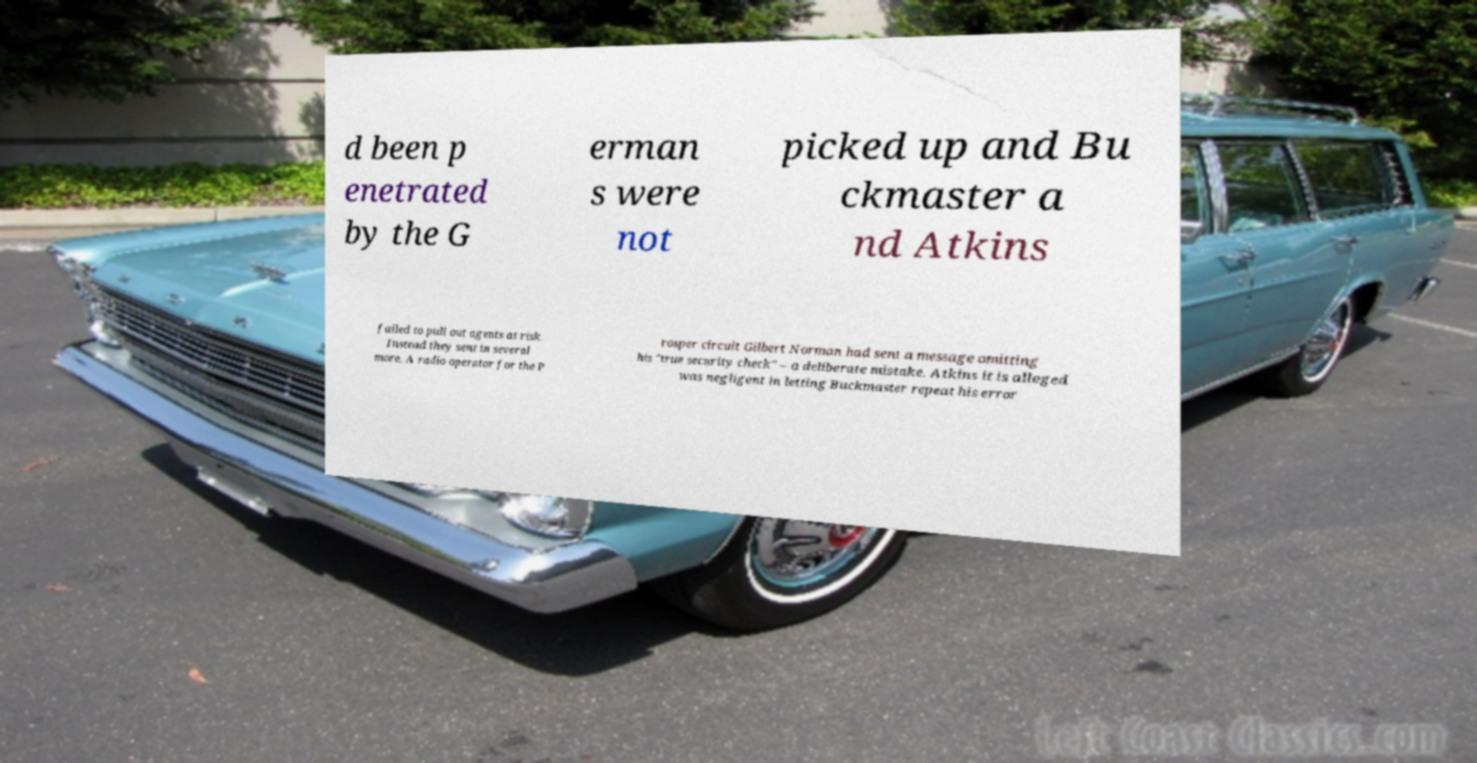Please read and relay the text visible in this image. What does it say? d been p enetrated by the G erman s were not picked up and Bu ckmaster a nd Atkins failed to pull out agents at risk. Instead they sent in several more. A radio operator for the P rosper circuit Gilbert Norman had sent a message omitting his "true security check" – a deliberate mistake. Atkins it is alleged was negligent in letting Buckmaster repeat his error 